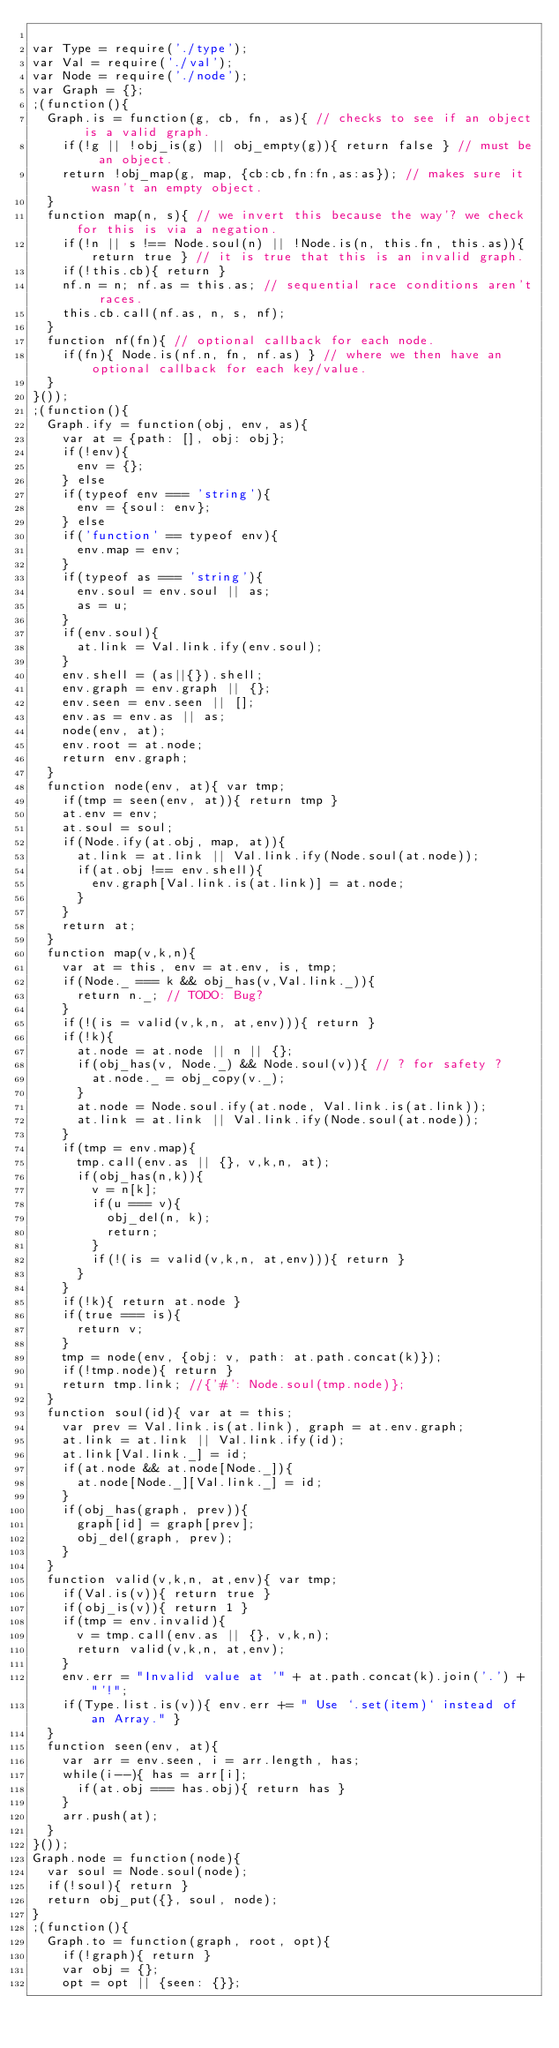<code> <loc_0><loc_0><loc_500><loc_500><_JavaScript_>
var Type = require('./type');
var Val = require('./val');
var Node = require('./node');
var Graph = {};
;(function(){
	Graph.is = function(g, cb, fn, as){ // checks to see if an object is a valid graph.
		if(!g || !obj_is(g) || obj_empty(g)){ return false } // must be an object.
		return !obj_map(g, map, {cb:cb,fn:fn,as:as}); // makes sure it wasn't an empty object.
	}
	function map(n, s){ // we invert this because the way'? we check for this is via a negation.
		if(!n || s !== Node.soul(n) || !Node.is(n, this.fn, this.as)){ return true } // it is true that this is an invalid graph.
		if(!this.cb){ return }
		nf.n = n; nf.as = this.as; // sequential race conditions aren't races.
		this.cb.call(nf.as, n, s, nf);
	}
	function nf(fn){ // optional callback for each node.
		if(fn){ Node.is(nf.n, fn, nf.as) } // where we then have an optional callback for each key/value.
	}
}());
;(function(){
	Graph.ify = function(obj, env, as){
		var at = {path: [], obj: obj};
		if(!env){
			env = {};
		} else
		if(typeof env === 'string'){
			env = {soul: env};
		} else
		if('function' == typeof env){
			env.map = env;
		}
		if(typeof as === 'string'){
			env.soul = env.soul || as;
			as = u;
		}
		if(env.soul){
			at.link = Val.link.ify(env.soul);
		}
		env.shell = (as||{}).shell;
		env.graph = env.graph || {};
		env.seen = env.seen || [];
		env.as = env.as || as;
		node(env, at);
		env.root = at.node;
		return env.graph;
	}
	function node(env, at){ var tmp;
		if(tmp = seen(env, at)){ return tmp }
		at.env = env;
		at.soul = soul;
		if(Node.ify(at.obj, map, at)){
			at.link = at.link || Val.link.ify(Node.soul(at.node));
			if(at.obj !== env.shell){
				env.graph[Val.link.is(at.link)] = at.node;
			}
		}
		return at;
	}
	function map(v,k,n){
		var at = this, env = at.env, is, tmp;
		if(Node._ === k && obj_has(v,Val.link._)){
			return n._; // TODO: Bug?
		}
		if(!(is = valid(v,k,n, at,env))){ return }
		if(!k){
			at.node = at.node || n || {};
			if(obj_has(v, Node._) && Node.soul(v)){ // ? for safety ?
				at.node._ = obj_copy(v._);
			}
			at.node = Node.soul.ify(at.node, Val.link.is(at.link));
			at.link = at.link || Val.link.ify(Node.soul(at.node));
		}
		if(tmp = env.map){
			tmp.call(env.as || {}, v,k,n, at);
			if(obj_has(n,k)){
				v = n[k];
				if(u === v){
					obj_del(n, k);
					return;
				}
				if(!(is = valid(v,k,n, at,env))){ return }
			}
		}
		if(!k){ return at.node }
		if(true === is){
			return v;
		}
		tmp = node(env, {obj: v, path: at.path.concat(k)});
		if(!tmp.node){ return }
		return tmp.link; //{'#': Node.soul(tmp.node)};
	}
	function soul(id){ var at = this;
		var prev = Val.link.is(at.link), graph = at.env.graph;
		at.link = at.link || Val.link.ify(id);
		at.link[Val.link._] = id;
		if(at.node && at.node[Node._]){
			at.node[Node._][Val.link._] = id;
		}
		if(obj_has(graph, prev)){
			graph[id] = graph[prev];
			obj_del(graph, prev);
		}
	}
	function valid(v,k,n, at,env){ var tmp;
		if(Val.is(v)){ return true }
		if(obj_is(v)){ return 1 }
		if(tmp = env.invalid){
			v = tmp.call(env.as || {}, v,k,n);
			return valid(v,k,n, at,env);
		}
		env.err = "Invalid value at '" + at.path.concat(k).join('.') + "'!";
		if(Type.list.is(v)){ env.err += " Use `.set(item)` instead of an Array." }
	}
	function seen(env, at){
		var arr = env.seen, i = arr.length, has;
		while(i--){ has = arr[i];
			if(at.obj === has.obj){ return has }
		}
		arr.push(at);
	}
}());
Graph.node = function(node){
	var soul = Node.soul(node);
	if(!soul){ return }
	return obj_put({}, soul, node);
}
;(function(){
	Graph.to = function(graph, root, opt){
		if(!graph){ return }
		var obj = {};
		opt = opt || {seen: {}};</code> 